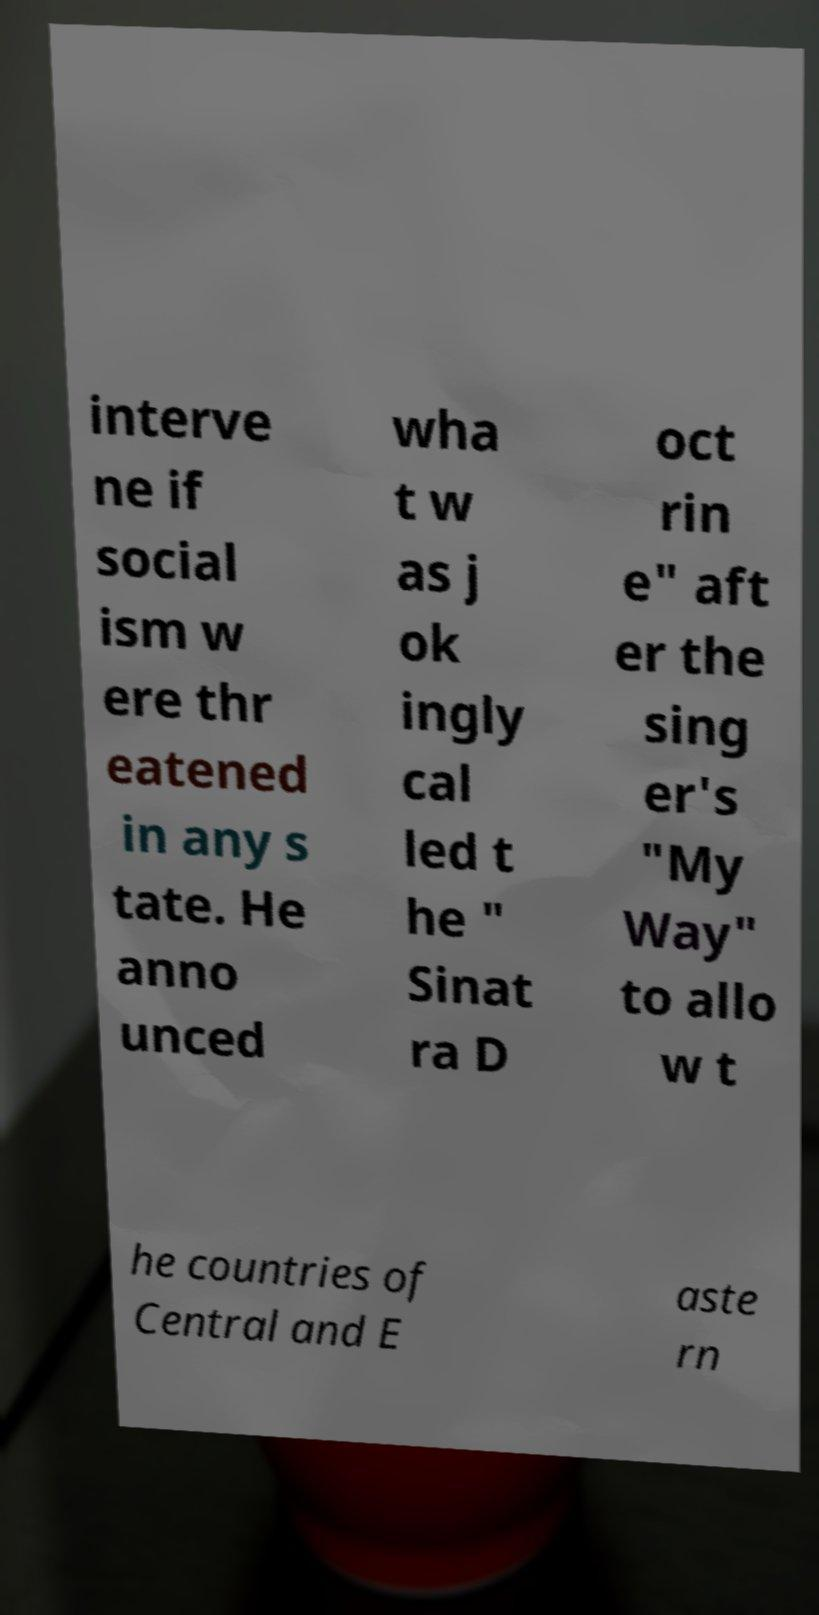What messages or text are displayed in this image? I need them in a readable, typed format. interve ne if social ism w ere thr eatened in any s tate. He anno unced wha t w as j ok ingly cal led t he " Sinat ra D oct rin e" aft er the sing er's "My Way" to allo w t he countries of Central and E aste rn 